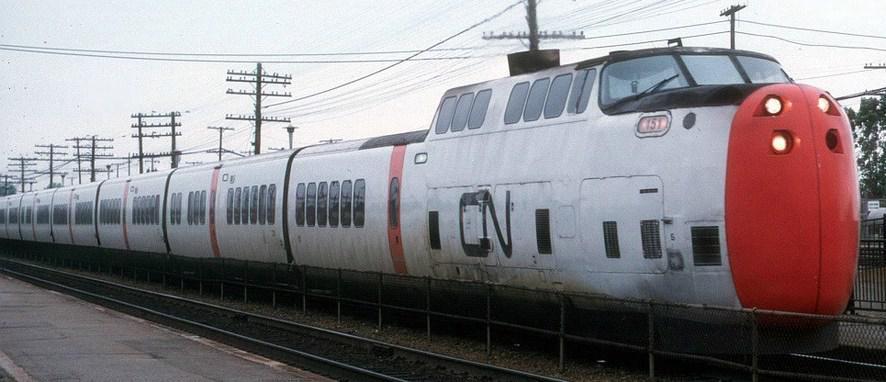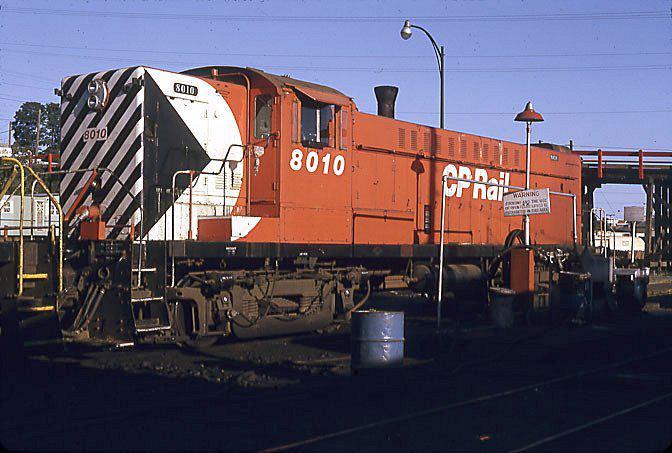The first image is the image on the left, the second image is the image on the right. Evaluate the accuracy of this statement regarding the images: "The right image includes at least one element with a pattern of bold diagonal lines near a red-orange train car.". Is it true? Answer yes or no. Yes. The first image is the image on the left, the second image is the image on the right. For the images shown, is this caption "One train car is mostly orange, with diagonal stripes at it's nose." true? Answer yes or no. Yes. 